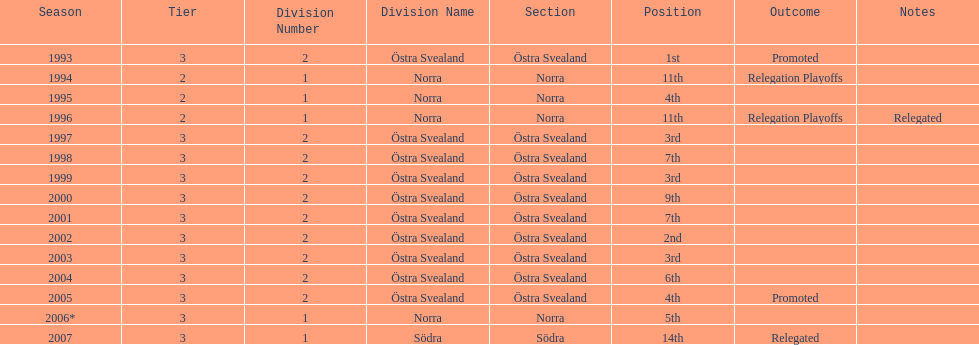In 2000 they finished 9th in their division, did they perform better or worse the next season? Better. 